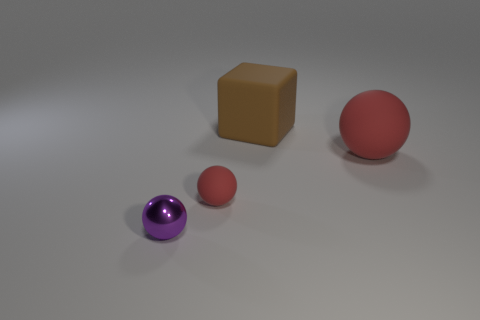The tiny rubber thing that is the same color as the large matte sphere is what shape?
Keep it short and to the point. Sphere. How many brown things have the same size as the rubber block?
Your answer should be compact. 0. There is a red rubber object that is in front of the big rubber sphere; what shape is it?
Offer a terse response. Sphere. Are there fewer small shiny things than red metallic spheres?
Your answer should be very brief. No. Is there anything else of the same color as the large block?
Provide a succinct answer. No. There is a red object right of the big brown object; what size is it?
Offer a very short reply. Large. Are there more small purple objects than matte balls?
Your answer should be compact. No. What material is the small red ball?
Provide a succinct answer. Rubber. What number of other things are the same material as the big red thing?
Ensure brevity in your answer.  2. What number of large things are there?
Keep it short and to the point. 2. 